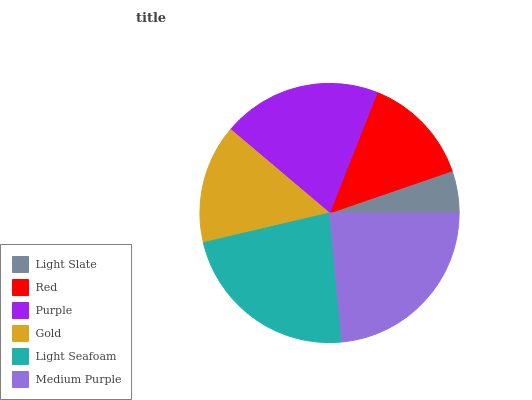Is Light Slate the minimum?
Answer yes or no. Yes. Is Medium Purple the maximum?
Answer yes or no. Yes. Is Red the minimum?
Answer yes or no. No. Is Red the maximum?
Answer yes or no. No. Is Red greater than Light Slate?
Answer yes or no. Yes. Is Light Slate less than Red?
Answer yes or no. Yes. Is Light Slate greater than Red?
Answer yes or no. No. Is Red less than Light Slate?
Answer yes or no. No. Is Purple the high median?
Answer yes or no. Yes. Is Gold the low median?
Answer yes or no. Yes. Is Light Seafoam the high median?
Answer yes or no. No. Is Red the low median?
Answer yes or no. No. 